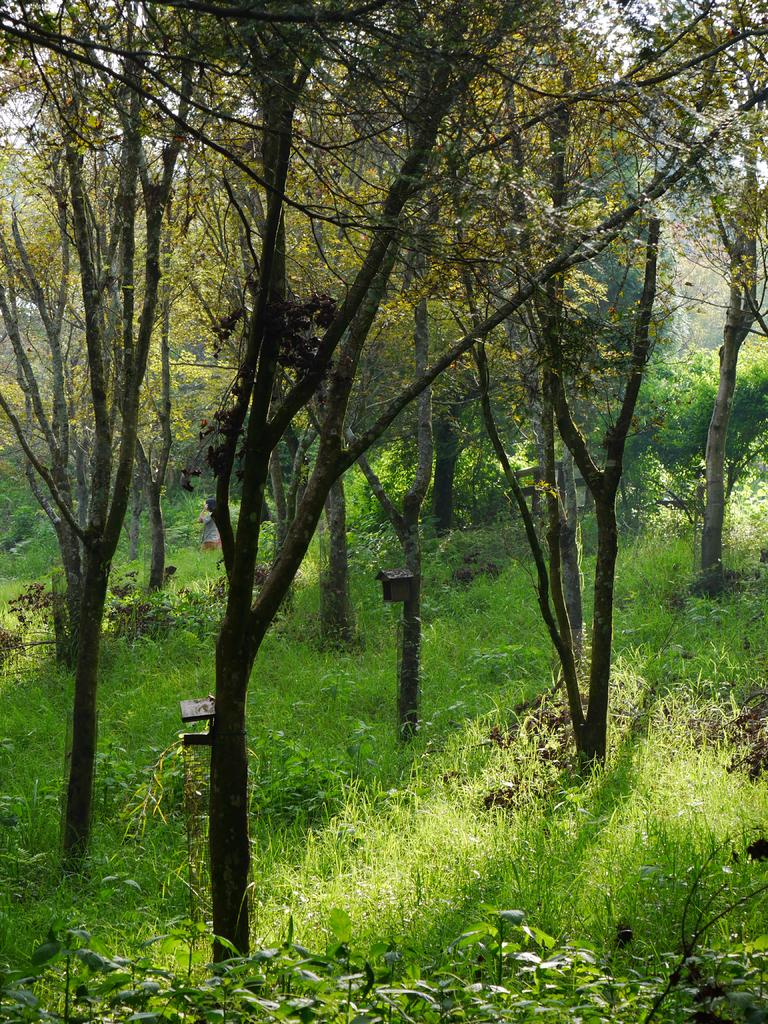What type of vegetation is visible in the image? There are trees and plants visible in the image. Can you describe the natural setting in the image? The natural setting includes trees and plants. What part of the environment is visible in the image? The sky is visible in the image. What is the current profit of the oven in the image? There is no oven present in the image, and therefore no profit can be associated with it. 